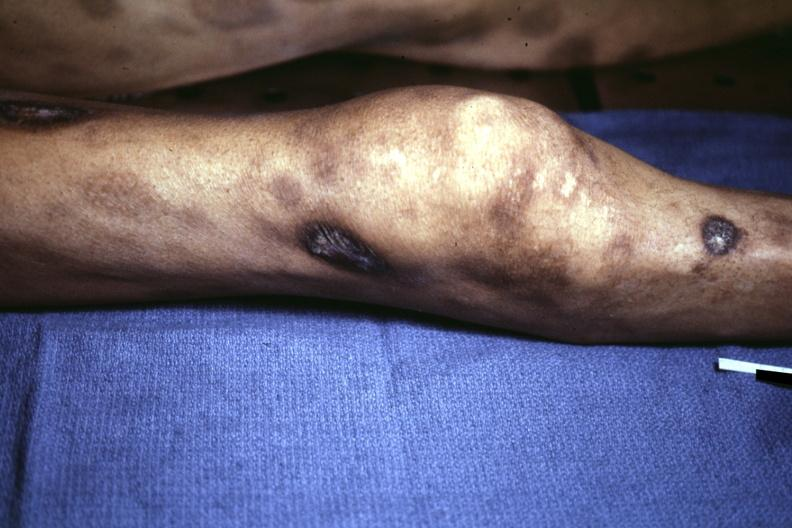what does necrotic and ulcerated centers look?
Answer the question using a single word or phrase. Like pyoderma gangrenosum 